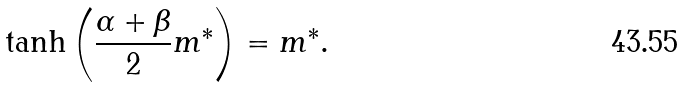Convert formula to latex. <formula><loc_0><loc_0><loc_500><loc_500>\tanh \left ( \frac { \alpha + \beta } { 2 } m ^ { * } \right ) = m ^ { * } .</formula> 